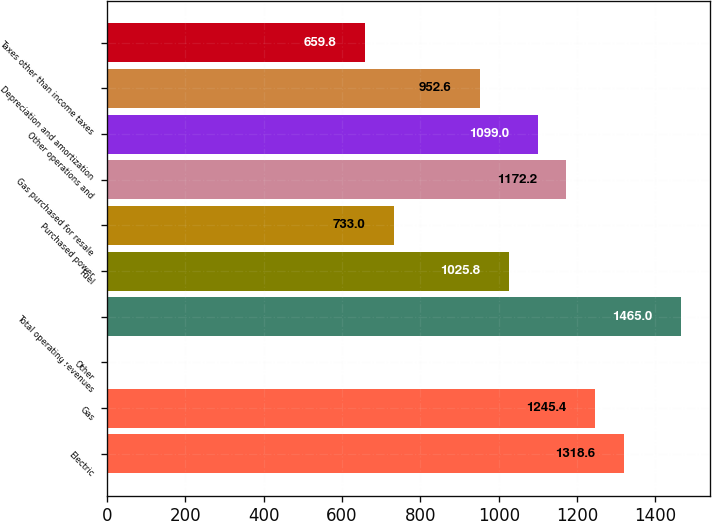<chart> <loc_0><loc_0><loc_500><loc_500><bar_chart><fcel>Electric<fcel>Gas<fcel>Other<fcel>Total operating revenues<fcel>Fuel<fcel>Purchased power<fcel>Gas purchased for resale<fcel>Other operations and<fcel>Depreciation and amortization<fcel>Taxes other than income taxes<nl><fcel>1318.6<fcel>1245.4<fcel>1<fcel>1465<fcel>1025.8<fcel>733<fcel>1172.2<fcel>1099<fcel>952.6<fcel>659.8<nl></chart> 